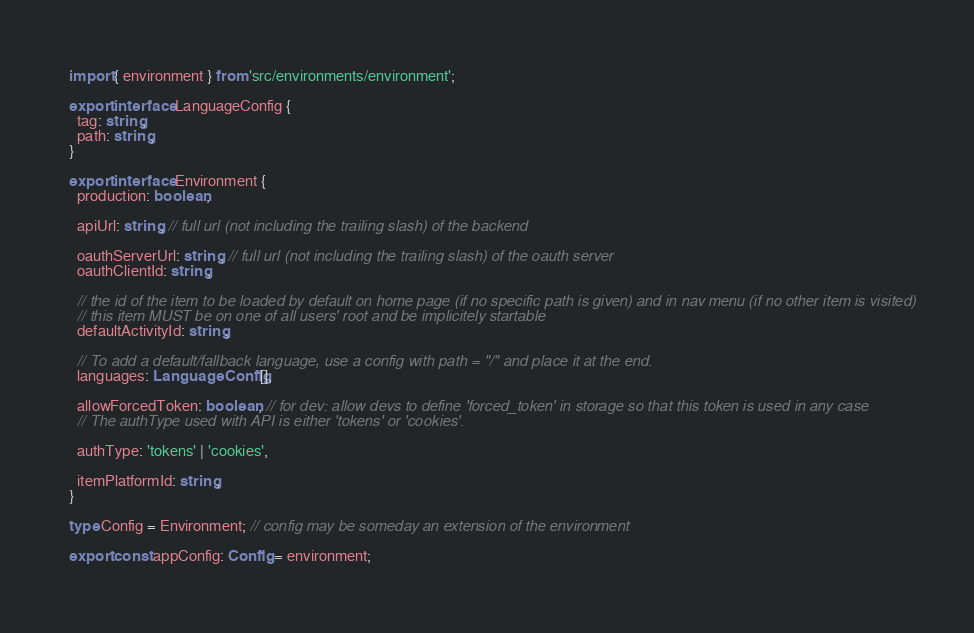<code> <loc_0><loc_0><loc_500><loc_500><_TypeScript_>import { environment } from 'src/environments/environment';

export interface LanguageConfig {
  tag: string,
  path: string,
}

export interface Environment {
  production: boolean,

  apiUrl: string, // full url (not including the trailing slash) of the backend

  oauthServerUrl: string, // full url (not including the trailing slash) of the oauth server
  oauthClientId: string,

  // the id of the item to be loaded by default on home page (if no specific path is given) and in nav menu (if no other item is visited)
  // this item MUST be on one of all users' root and be implicitely startable
  defaultActivityId: string,

  // To add a default/fallback language, use a config with path = "/" and place it at the end.
  languages: LanguageConfig[],

  allowForcedToken: boolean, // for dev: allow devs to define 'forced_token' in storage so that this token is used in any case
  // The authType used with API is either 'tokens' or 'cookies'.

  authType: 'tokens' | 'cookies',

  itemPlatformId: string,
}

type Config = Environment; // config may be someday an extension of the environment

export const appConfig: Config = environment;
</code> 